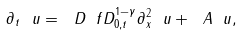Convert formula to latex. <formula><loc_0><loc_0><loc_500><loc_500>\partial _ { t } \ u = \ D \ f D _ { 0 , t } ^ { 1 - \gamma } \partial _ { x } ^ { 2 } \ u + \ A \ u ,</formula> 